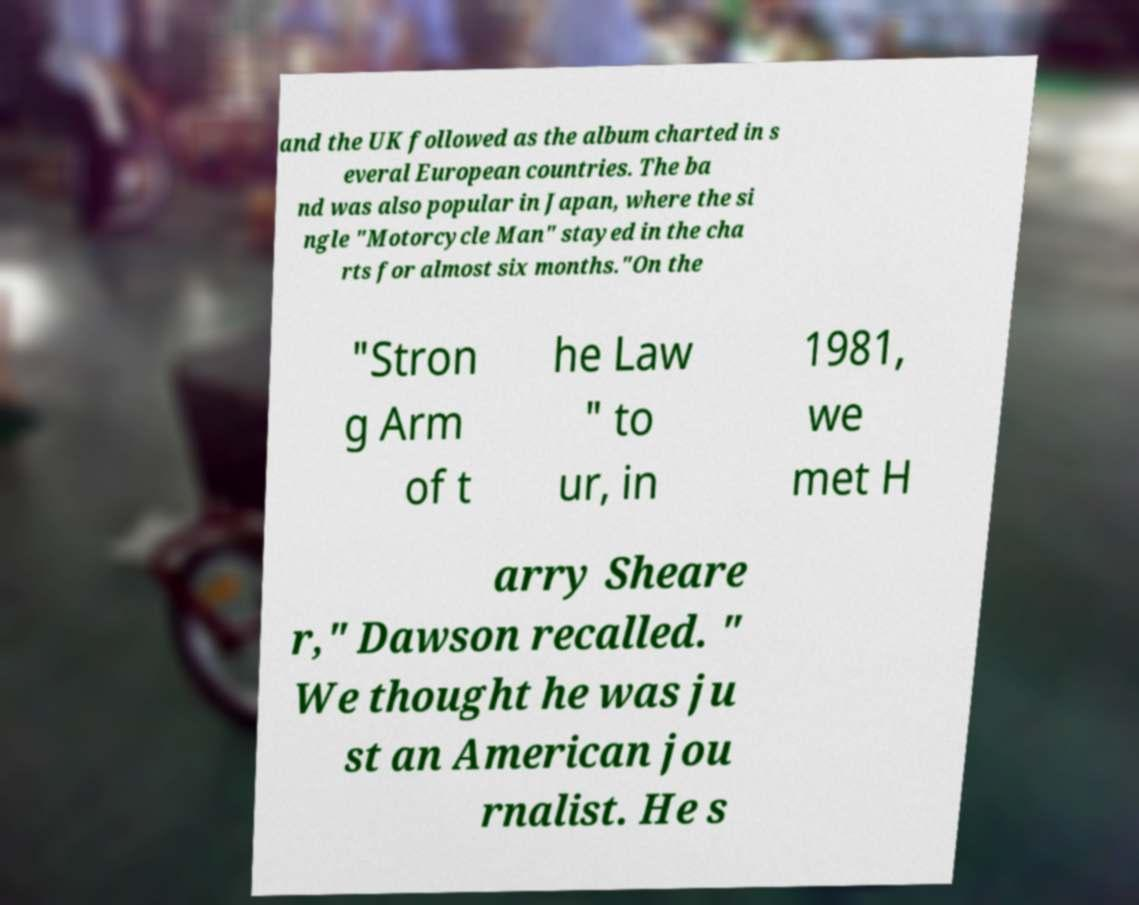Could you extract and type out the text from this image? and the UK followed as the album charted in s everal European countries. The ba nd was also popular in Japan, where the si ngle "Motorcycle Man" stayed in the cha rts for almost six months."On the "Stron g Arm of t he Law " to ur, in 1981, we met H arry Sheare r," Dawson recalled. " We thought he was ju st an American jou rnalist. He s 